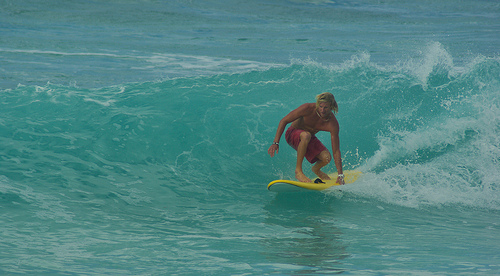Is the surfer on top of the surfboard wearing a wetsuit? No, the surfer is not wearing a wetsuit; instead, he is dressed in swim shorts, suitable for the warm water conditions. 